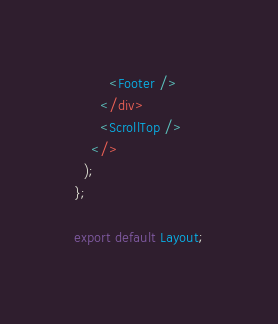Convert code to text. <code><loc_0><loc_0><loc_500><loc_500><_TypeScript_>        <Footer />
      </div>
      <ScrollTop />
    </>
  );
};

export default Layout;
</code> 